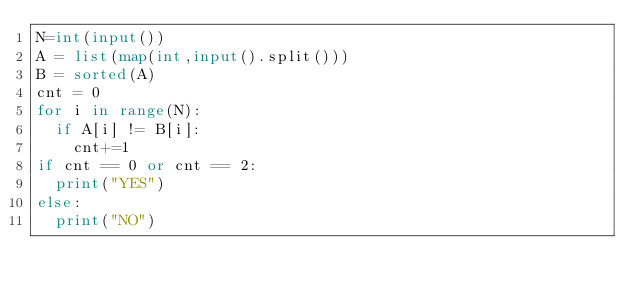<code> <loc_0><loc_0><loc_500><loc_500><_Python_>N=int(input())
A = list(map(int,input().split()))
B = sorted(A)
cnt = 0
for i in range(N):
  if A[i] != B[i]:
    cnt+=1
if cnt == 0 or cnt == 2:
  print("YES")
else:
  print("NO")
</code> 